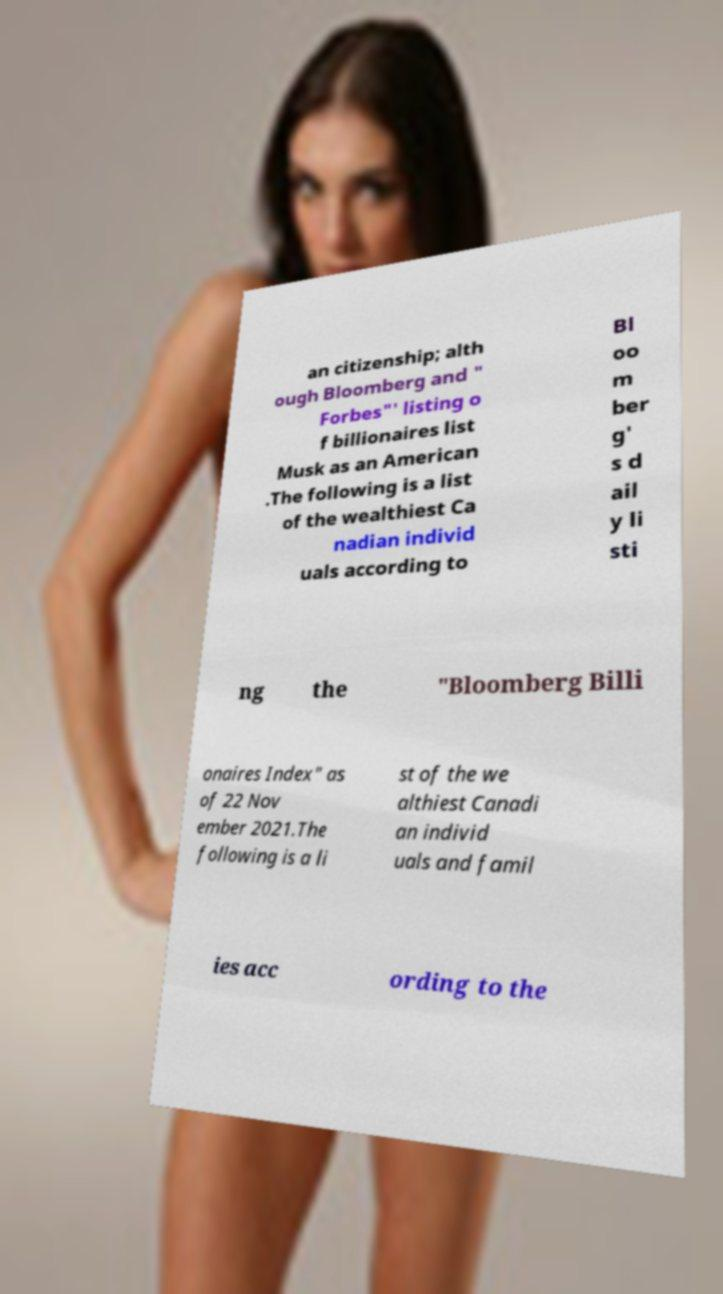There's text embedded in this image that I need extracted. Can you transcribe it verbatim? an citizenship; alth ough Bloomberg and " Forbes"' listing o f billionaires list Musk as an American .The following is a list of the wealthiest Ca nadian individ uals according to Bl oo m ber g' s d ail y li sti ng the "Bloomberg Billi onaires Index" as of 22 Nov ember 2021.The following is a li st of the we althiest Canadi an individ uals and famil ies acc ording to the 